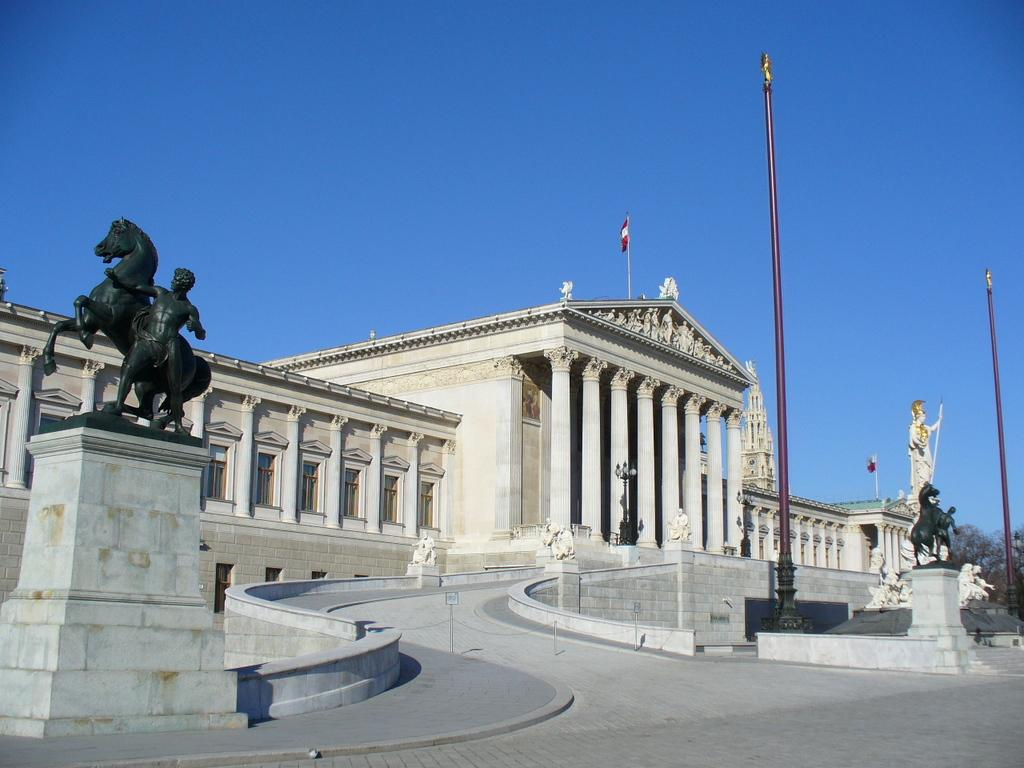What can be seen in the foreground of the picture? In the foreground of the picture, there are sculptures, a path, poles, a building, and a flag. What is located on the right side of the picture? There are trees on the right side of the picture. What is visible at the top of the picture? The sky is visible at the top of the picture. What is the texture of the servant's clothing in the image? There is no servant present in the image, so we cannot determine the texture of their clothing. 